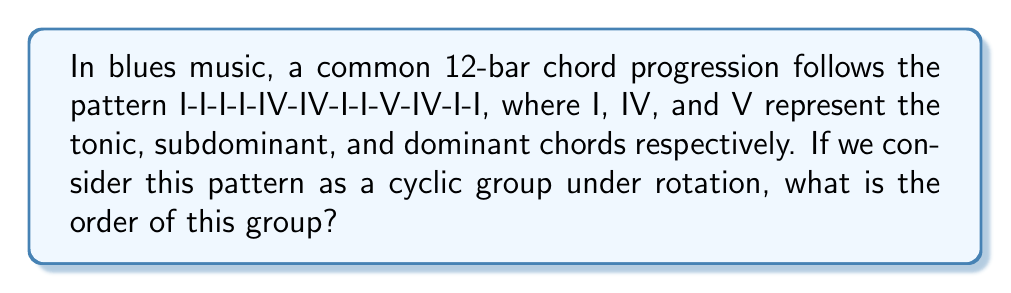Solve this math problem. To determine the order of the cyclic group formed by this musical pattern, we need to follow these steps:

1) First, let's represent the pattern as a sequence:
   $$(I,I,I,I,IV,IV,I,I,V,IV,I,I)$$

2) The order of a cyclic group is the smallest positive integer $n$ such that rotating the sequence $n$ times brings us back to the original sequence.

3) Let's examine the rotations:
   - 1 rotation: $(I,I,I,IV,IV,I,I,V,IV,I,I,I)$ (different from original)
   - 2 rotations: $(I,I,IV,IV,I,I,V,IV,I,I,I,I)$ (different from original)
   ...
   - 11 rotations: $(I,I,I,I,IV,IV,I,I,V,IV,I,I)$ (same as original)

4) We see that it takes 12 rotations to return to the original sequence. This is because the pattern has 12 elements, and each element is unique in its position.

5) In group theory terms, this means that the generator of the group (our original sequence) has order 12.

6) Therefore, the cyclic group formed by this chord progression has order 12.

This result aligns with the musical structure of the 12-bar blues, where the full progression repeats after 12 bars.
Answer: The order of the cyclic group is 12. 